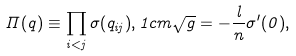<formula> <loc_0><loc_0><loc_500><loc_500>\Pi ( q ) \equiv \prod _ { i < j } \sigma ( q _ { i j } ) , 1 c m \sqrt { g } = - \frac { l } { n } \sigma ^ { \prime } ( 0 ) ,</formula> 